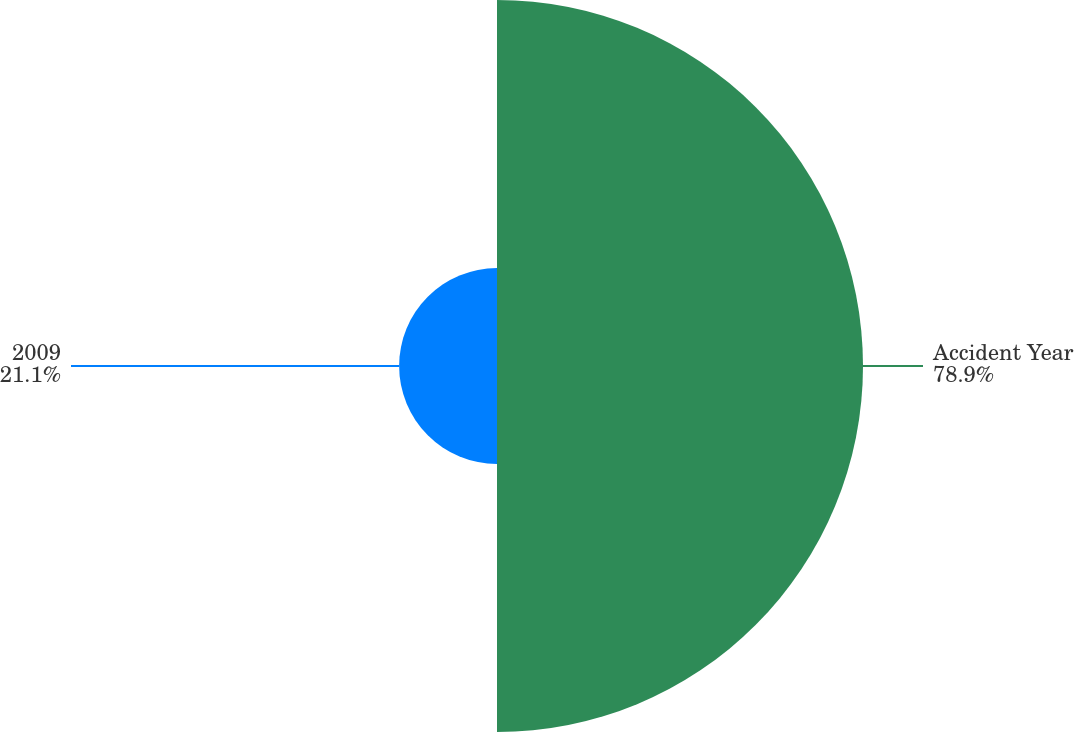Convert chart. <chart><loc_0><loc_0><loc_500><loc_500><pie_chart><fcel>Accident Year<fcel>2009<nl><fcel>78.9%<fcel>21.1%<nl></chart> 